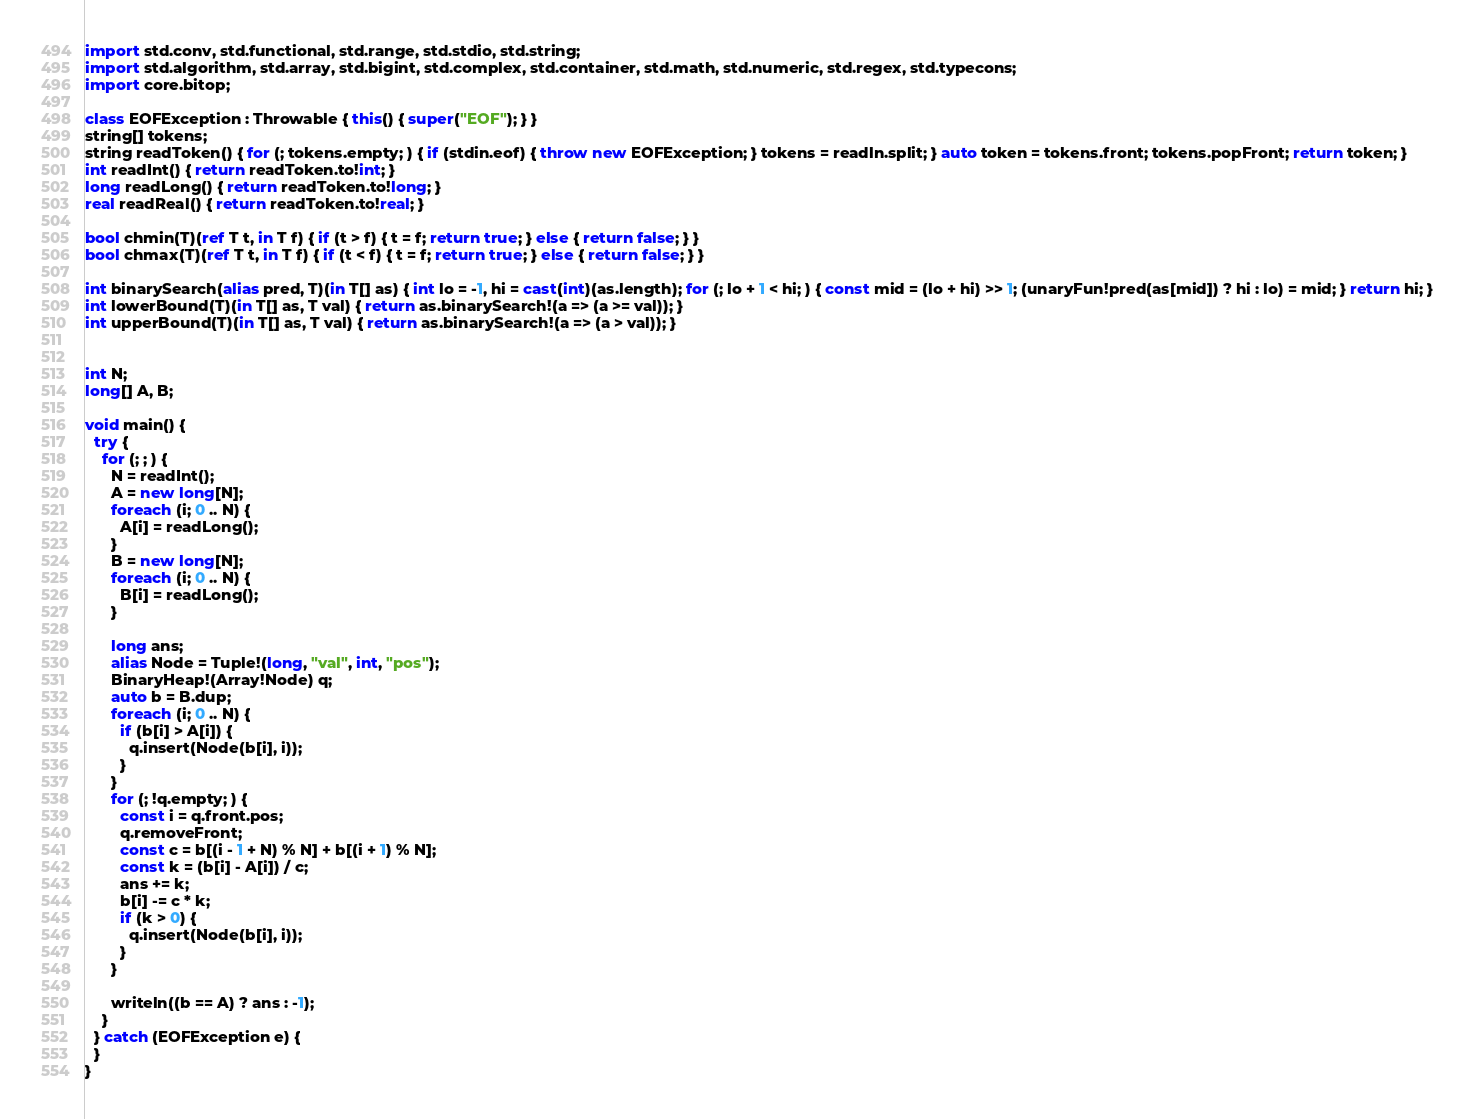<code> <loc_0><loc_0><loc_500><loc_500><_D_>import std.conv, std.functional, std.range, std.stdio, std.string;
import std.algorithm, std.array, std.bigint, std.complex, std.container, std.math, std.numeric, std.regex, std.typecons;
import core.bitop;

class EOFException : Throwable { this() { super("EOF"); } }
string[] tokens;
string readToken() { for (; tokens.empty; ) { if (stdin.eof) { throw new EOFException; } tokens = readln.split; } auto token = tokens.front; tokens.popFront; return token; }
int readInt() { return readToken.to!int; }
long readLong() { return readToken.to!long; }
real readReal() { return readToken.to!real; }

bool chmin(T)(ref T t, in T f) { if (t > f) { t = f; return true; } else { return false; } }
bool chmax(T)(ref T t, in T f) { if (t < f) { t = f; return true; } else { return false; } }

int binarySearch(alias pred, T)(in T[] as) { int lo = -1, hi = cast(int)(as.length); for (; lo + 1 < hi; ) { const mid = (lo + hi) >> 1; (unaryFun!pred(as[mid]) ? hi : lo) = mid; } return hi; }
int lowerBound(T)(in T[] as, T val) { return as.binarySearch!(a => (a >= val)); }
int upperBound(T)(in T[] as, T val) { return as.binarySearch!(a => (a > val)); }


int N;
long[] A, B;

void main() {
  try {
    for (; ; ) {
      N = readInt();
      A = new long[N];
      foreach (i; 0 .. N) {
        A[i] = readLong();
      }
      B = new long[N];
      foreach (i; 0 .. N) {
        B[i] = readLong();
      }
      
      long ans;
      alias Node = Tuple!(long, "val", int, "pos");
      BinaryHeap!(Array!Node) q;
      auto b = B.dup;
      foreach (i; 0 .. N) {
        if (b[i] > A[i]) {
          q.insert(Node(b[i], i));
        }
      }
      for (; !q.empty; ) {
        const i = q.front.pos;
        q.removeFront;
        const c = b[(i - 1 + N) % N] + b[(i + 1) % N];
        const k = (b[i] - A[i]) / c;
        ans += k;
        b[i] -= c * k;
        if (k > 0) {
          q.insert(Node(b[i], i));
        }
      }
      
      writeln((b == A) ? ans : -1);
    }
  } catch (EOFException e) {
  }
}
</code> 